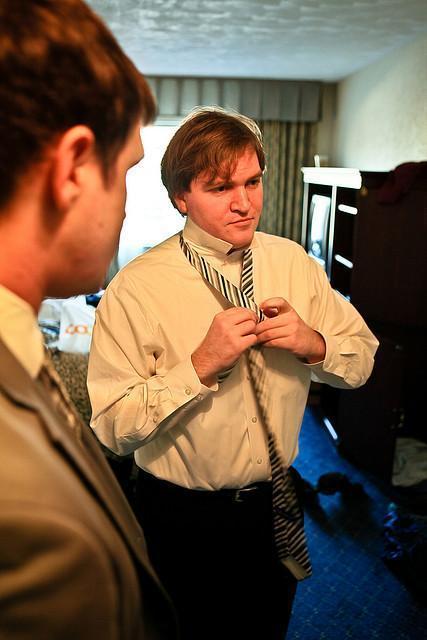How many people are visible?
Give a very brief answer. 2. How many boats are clearly visible in the water?
Give a very brief answer. 0. 